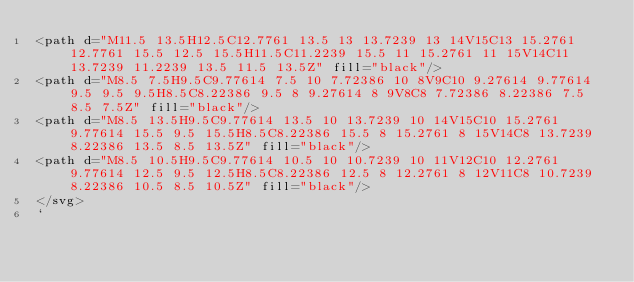Convert code to text. <code><loc_0><loc_0><loc_500><loc_500><_TypeScript_><path d="M11.5 13.5H12.5C12.7761 13.5 13 13.7239 13 14V15C13 15.2761 12.7761 15.5 12.5 15.5H11.5C11.2239 15.5 11 15.2761 11 15V14C11 13.7239 11.2239 13.5 11.5 13.5Z" fill="black"/>
<path d="M8.5 7.5H9.5C9.77614 7.5 10 7.72386 10 8V9C10 9.27614 9.77614 9.5 9.5 9.5H8.5C8.22386 9.5 8 9.27614 8 9V8C8 7.72386 8.22386 7.5 8.5 7.5Z" fill="black"/>
<path d="M8.5 13.5H9.5C9.77614 13.5 10 13.7239 10 14V15C10 15.2761 9.77614 15.5 9.5 15.5H8.5C8.22386 15.5 8 15.2761 8 15V14C8 13.7239 8.22386 13.5 8.5 13.5Z" fill="black"/>
<path d="M8.5 10.5H9.5C9.77614 10.5 10 10.7239 10 11V12C10 12.2761 9.77614 12.5 9.5 12.5H8.5C8.22386 12.5 8 12.2761 8 12V11C8 10.7239 8.22386 10.5 8.5 10.5Z" fill="black"/>
</svg>
`
</code> 